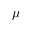Convert formula to latex. <formula><loc_0><loc_0><loc_500><loc_500>\mu</formula> 